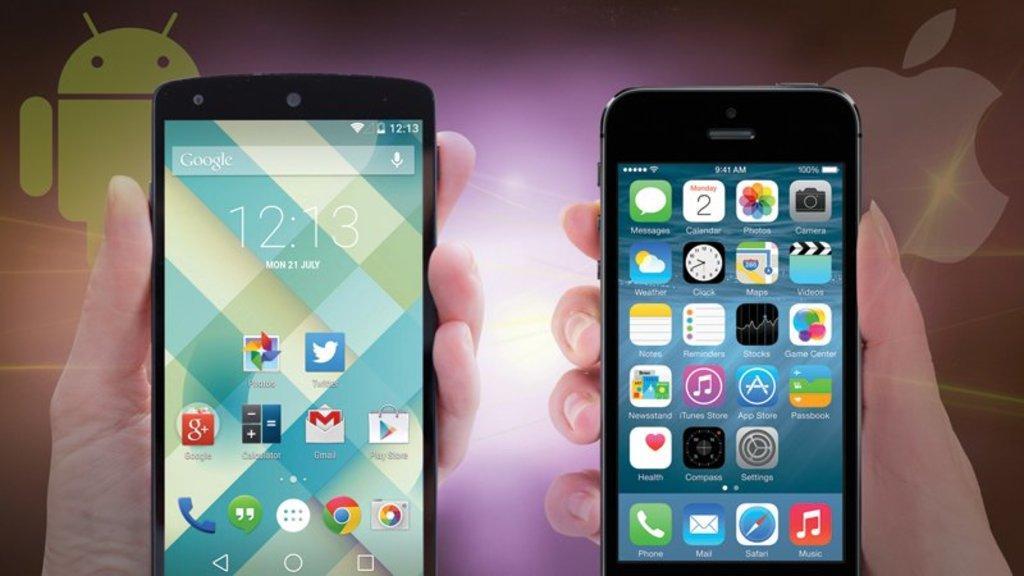Could you give a brief overview of what you see in this image? This is an edited picture. In this picture we can see the hands of people holding mobiles. In the background we can see the logos. 